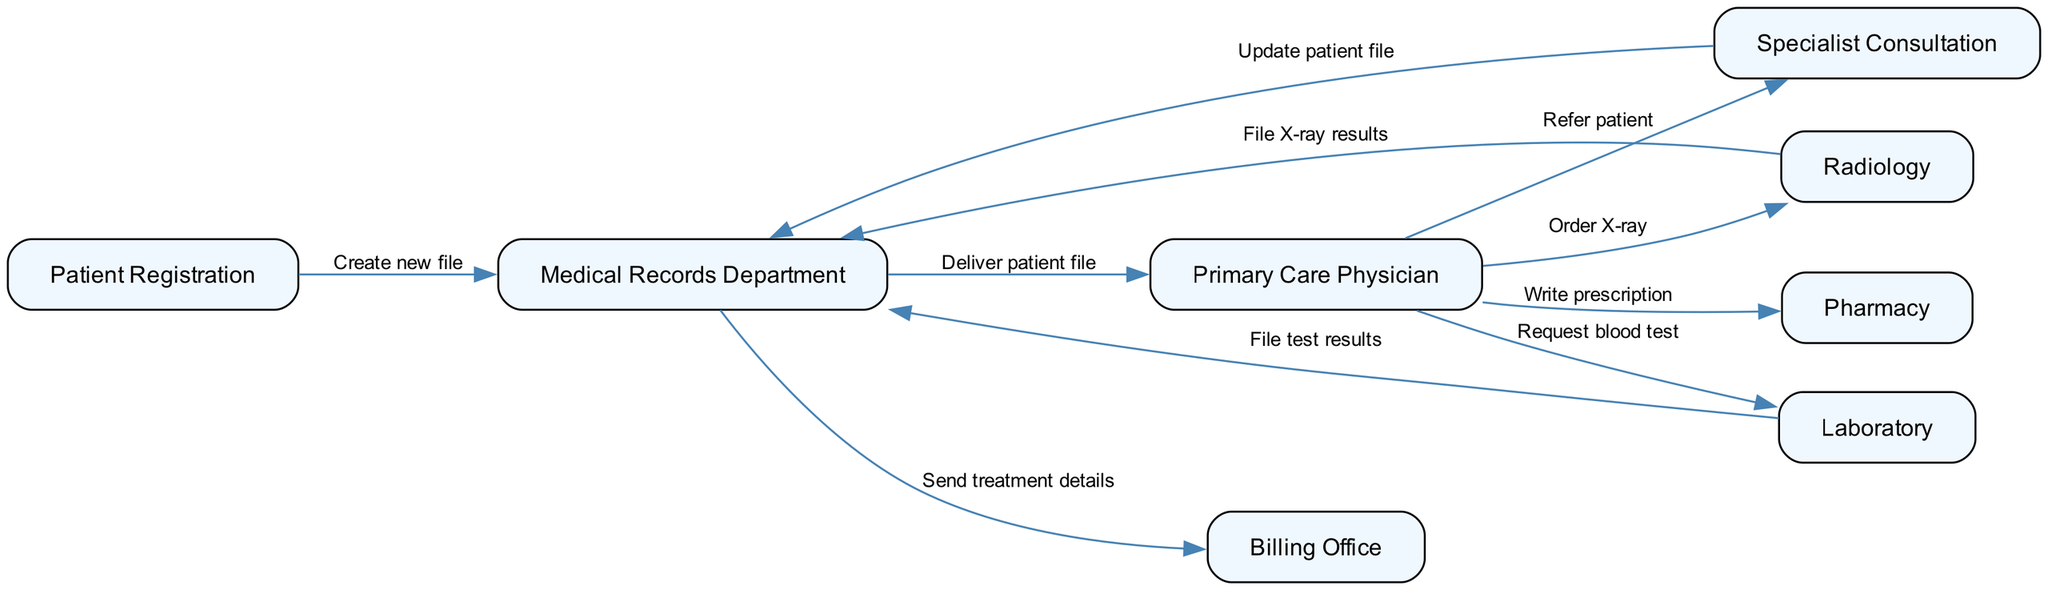What is the first step in the flow of paper medical records? The flow begins with "Patient Registration," where a new patient file is created.
Answer: Patient Registration How many departments are involved in the paper medical records flow? Counting the nodes listed, there are eight distinct departments involved in the process.
Answer: Eight What does the Primary Care Physician do after receiving the patient file? The Primary Care Physician may either refer the patient for specialist consultation, order an X-ray, or request blood tests, as depicted in the edges emanating from this node.
Answer: Refer patient, Order X-ray, Request blood test Which department receives updates from the Specialist Consultation? The updates from the Specialist Consultation are sent to the Medical Records Department, where patient files are updated.
Answer: Medical Records Department What is the last step in the paper medical records flow? The final step is sending treatment details from the Medical Records Department to the Billing Office.
Answer: Billing Office How many edges connect the Medical Records Department to other departments? There are four edges originating from the Medical Records Department that connect it to other departments in the flow.
Answer: Four If the Primary Care Physician orders an X-ray, which node receives the results? The results from the Radiology department flow back to the Medical Records Department after the X-ray is performed.
Answer: Medical Records Department In which department is the patient file created? The patient file is created during the initial step at the Patient Registration department.
Answer: Patient Registration 